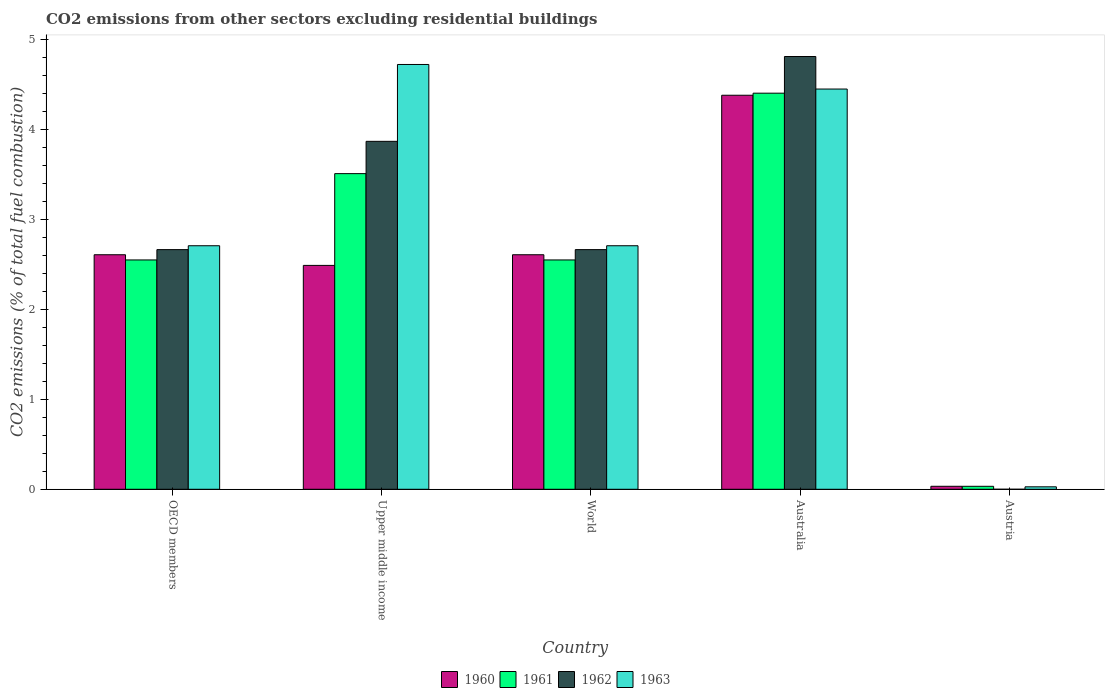How many groups of bars are there?
Give a very brief answer. 5. Are the number of bars per tick equal to the number of legend labels?
Your answer should be compact. No. How many bars are there on the 5th tick from the right?
Make the answer very short. 4. What is the label of the 4th group of bars from the left?
Your answer should be very brief. Australia. In how many cases, is the number of bars for a given country not equal to the number of legend labels?
Provide a succinct answer. 1. What is the total CO2 emitted in 1962 in Australia?
Provide a short and direct response. 4.82. Across all countries, what is the maximum total CO2 emitted in 1963?
Make the answer very short. 4.73. Across all countries, what is the minimum total CO2 emitted in 1962?
Your answer should be very brief. 0. In which country was the total CO2 emitted in 1963 maximum?
Ensure brevity in your answer.  Upper middle income. What is the total total CO2 emitted in 1960 in the graph?
Make the answer very short. 12.13. What is the difference between the total CO2 emitted in 1963 in Australia and that in Upper middle income?
Ensure brevity in your answer.  -0.27. What is the difference between the total CO2 emitted in 1961 in Upper middle income and the total CO2 emitted in 1962 in World?
Give a very brief answer. 0.85. What is the average total CO2 emitted in 1960 per country?
Provide a succinct answer. 2.43. What is the difference between the total CO2 emitted of/in 1963 and total CO2 emitted of/in 1962 in OECD members?
Offer a very short reply. 0.04. What is the ratio of the total CO2 emitted in 1960 in Australia to that in Austria?
Give a very brief answer. 131.83. Is the total CO2 emitted in 1963 in Austria less than that in Upper middle income?
Give a very brief answer. Yes. What is the difference between the highest and the second highest total CO2 emitted in 1960?
Offer a terse response. -1.77. What is the difference between the highest and the lowest total CO2 emitted in 1962?
Offer a very short reply. 4.82. In how many countries, is the total CO2 emitted in 1963 greater than the average total CO2 emitted in 1963 taken over all countries?
Give a very brief answer. 2. Is it the case that in every country, the sum of the total CO2 emitted in 1961 and total CO2 emitted in 1963 is greater than the total CO2 emitted in 1960?
Your response must be concise. Yes. How many bars are there?
Provide a short and direct response. 19. Are all the bars in the graph horizontal?
Ensure brevity in your answer.  No. Does the graph contain any zero values?
Keep it short and to the point. Yes. Where does the legend appear in the graph?
Make the answer very short. Bottom center. How many legend labels are there?
Keep it short and to the point. 4. How are the legend labels stacked?
Ensure brevity in your answer.  Horizontal. What is the title of the graph?
Offer a very short reply. CO2 emissions from other sectors excluding residential buildings. Does "1961" appear as one of the legend labels in the graph?
Give a very brief answer. Yes. What is the label or title of the X-axis?
Keep it short and to the point. Country. What is the label or title of the Y-axis?
Your response must be concise. CO2 emissions (% of total fuel combustion). What is the CO2 emissions (% of total fuel combustion) of 1960 in OECD members?
Offer a terse response. 2.61. What is the CO2 emissions (% of total fuel combustion) of 1961 in OECD members?
Your answer should be compact. 2.55. What is the CO2 emissions (% of total fuel combustion) in 1962 in OECD members?
Offer a very short reply. 2.67. What is the CO2 emissions (% of total fuel combustion) in 1963 in OECD members?
Keep it short and to the point. 2.71. What is the CO2 emissions (% of total fuel combustion) of 1960 in Upper middle income?
Give a very brief answer. 2.49. What is the CO2 emissions (% of total fuel combustion) of 1961 in Upper middle income?
Your response must be concise. 3.51. What is the CO2 emissions (% of total fuel combustion) in 1962 in Upper middle income?
Ensure brevity in your answer.  3.87. What is the CO2 emissions (% of total fuel combustion) in 1963 in Upper middle income?
Provide a short and direct response. 4.73. What is the CO2 emissions (% of total fuel combustion) of 1960 in World?
Ensure brevity in your answer.  2.61. What is the CO2 emissions (% of total fuel combustion) of 1961 in World?
Offer a very short reply. 2.55. What is the CO2 emissions (% of total fuel combustion) of 1962 in World?
Your answer should be very brief. 2.67. What is the CO2 emissions (% of total fuel combustion) in 1963 in World?
Your answer should be compact. 2.71. What is the CO2 emissions (% of total fuel combustion) in 1960 in Australia?
Offer a very short reply. 4.38. What is the CO2 emissions (% of total fuel combustion) of 1961 in Australia?
Offer a terse response. 4.41. What is the CO2 emissions (% of total fuel combustion) of 1962 in Australia?
Your answer should be very brief. 4.82. What is the CO2 emissions (% of total fuel combustion) in 1963 in Australia?
Provide a succinct answer. 4.45. What is the CO2 emissions (% of total fuel combustion) in 1960 in Austria?
Offer a very short reply. 0.03. What is the CO2 emissions (% of total fuel combustion) of 1961 in Austria?
Provide a succinct answer. 0.03. What is the CO2 emissions (% of total fuel combustion) in 1962 in Austria?
Provide a succinct answer. 0. What is the CO2 emissions (% of total fuel combustion) of 1963 in Austria?
Give a very brief answer. 0.03. Across all countries, what is the maximum CO2 emissions (% of total fuel combustion) of 1960?
Your answer should be compact. 4.38. Across all countries, what is the maximum CO2 emissions (% of total fuel combustion) of 1961?
Your response must be concise. 4.41. Across all countries, what is the maximum CO2 emissions (% of total fuel combustion) in 1962?
Provide a succinct answer. 4.82. Across all countries, what is the maximum CO2 emissions (% of total fuel combustion) of 1963?
Keep it short and to the point. 4.73. Across all countries, what is the minimum CO2 emissions (% of total fuel combustion) of 1960?
Provide a succinct answer. 0.03. Across all countries, what is the minimum CO2 emissions (% of total fuel combustion) of 1961?
Give a very brief answer. 0.03. Across all countries, what is the minimum CO2 emissions (% of total fuel combustion) of 1962?
Provide a succinct answer. 0. Across all countries, what is the minimum CO2 emissions (% of total fuel combustion) of 1963?
Give a very brief answer. 0.03. What is the total CO2 emissions (% of total fuel combustion) in 1960 in the graph?
Provide a succinct answer. 12.13. What is the total CO2 emissions (% of total fuel combustion) in 1961 in the graph?
Provide a short and direct response. 13.06. What is the total CO2 emissions (% of total fuel combustion) of 1962 in the graph?
Offer a very short reply. 14.02. What is the total CO2 emissions (% of total fuel combustion) in 1963 in the graph?
Give a very brief answer. 14.63. What is the difference between the CO2 emissions (% of total fuel combustion) of 1960 in OECD members and that in Upper middle income?
Provide a succinct answer. 0.12. What is the difference between the CO2 emissions (% of total fuel combustion) in 1961 in OECD members and that in Upper middle income?
Provide a short and direct response. -0.96. What is the difference between the CO2 emissions (% of total fuel combustion) of 1962 in OECD members and that in Upper middle income?
Offer a very short reply. -1.2. What is the difference between the CO2 emissions (% of total fuel combustion) in 1963 in OECD members and that in Upper middle income?
Your answer should be compact. -2.02. What is the difference between the CO2 emissions (% of total fuel combustion) of 1960 in OECD members and that in Australia?
Provide a succinct answer. -1.77. What is the difference between the CO2 emissions (% of total fuel combustion) in 1961 in OECD members and that in Australia?
Provide a succinct answer. -1.86. What is the difference between the CO2 emissions (% of total fuel combustion) in 1962 in OECD members and that in Australia?
Your answer should be very brief. -2.15. What is the difference between the CO2 emissions (% of total fuel combustion) in 1963 in OECD members and that in Australia?
Give a very brief answer. -1.74. What is the difference between the CO2 emissions (% of total fuel combustion) of 1960 in OECD members and that in Austria?
Ensure brevity in your answer.  2.58. What is the difference between the CO2 emissions (% of total fuel combustion) in 1961 in OECD members and that in Austria?
Your answer should be very brief. 2.52. What is the difference between the CO2 emissions (% of total fuel combustion) of 1963 in OECD members and that in Austria?
Your response must be concise. 2.68. What is the difference between the CO2 emissions (% of total fuel combustion) in 1960 in Upper middle income and that in World?
Your response must be concise. -0.12. What is the difference between the CO2 emissions (% of total fuel combustion) in 1961 in Upper middle income and that in World?
Ensure brevity in your answer.  0.96. What is the difference between the CO2 emissions (% of total fuel combustion) of 1962 in Upper middle income and that in World?
Give a very brief answer. 1.2. What is the difference between the CO2 emissions (% of total fuel combustion) of 1963 in Upper middle income and that in World?
Your answer should be very brief. 2.02. What is the difference between the CO2 emissions (% of total fuel combustion) in 1960 in Upper middle income and that in Australia?
Your answer should be compact. -1.89. What is the difference between the CO2 emissions (% of total fuel combustion) of 1961 in Upper middle income and that in Australia?
Offer a terse response. -0.9. What is the difference between the CO2 emissions (% of total fuel combustion) of 1962 in Upper middle income and that in Australia?
Offer a very short reply. -0.94. What is the difference between the CO2 emissions (% of total fuel combustion) in 1963 in Upper middle income and that in Australia?
Offer a very short reply. 0.27. What is the difference between the CO2 emissions (% of total fuel combustion) of 1960 in Upper middle income and that in Austria?
Ensure brevity in your answer.  2.46. What is the difference between the CO2 emissions (% of total fuel combustion) in 1961 in Upper middle income and that in Austria?
Offer a terse response. 3.48. What is the difference between the CO2 emissions (% of total fuel combustion) in 1963 in Upper middle income and that in Austria?
Your response must be concise. 4.7. What is the difference between the CO2 emissions (% of total fuel combustion) of 1960 in World and that in Australia?
Make the answer very short. -1.77. What is the difference between the CO2 emissions (% of total fuel combustion) of 1961 in World and that in Australia?
Give a very brief answer. -1.86. What is the difference between the CO2 emissions (% of total fuel combustion) of 1962 in World and that in Australia?
Make the answer very short. -2.15. What is the difference between the CO2 emissions (% of total fuel combustion) of 1963 in World and that in Australia?
Give a very brief answer. -1.74. What is the difference between the CO2 emissions (% of total fuel combustion) of 1960 in World and that in Austria?
Ensure brevity in your answer.  2.58. What is the difference between the CO2 emissions (% of total fuel combustion) of 1961 in World and that in Austria?
Your response must be concise. 2.52. What is the difference between the CO2 emissions (% of total fuel combustion) in 1963 in World and that in Austria?
Keep it short and to the point. 2.68. What is the difference between the CO2 emissions (% of total fuel combustion) of 1960 in Australia and that in Austria?
Offer a terse response. 4.35. What is the difference between the CO2 emissions (% of total fuel combustion) of 1961 in Australia and that in Austria?
Provide a succinct answer. 4.37. What is the difference between the CO2 emissions (% of total fuel combustion) of 1963 in Australia and that in Austria?
Your answer should be compact. 4.43. What is the difference between the CO2 emissions (% of total fuel combustion) of 1960 in OECD members and the CO2 emissions (% of total fuel combustion) of 1961 in Upper middle income?
Your answer should be compact. -0.9. What is the difference between the CO2 emissions (% of total fuel combustion) of 1960 in OECD members and the CO2 emissions (% of total fuel combustion) of 1962 in Upper middle income?
Offer a terse response. -1.26. What is the difference between the CO2 emissions (% of total fuel combustion) in 1960 in OECD members and the CO2 emissions (% of total fuel combustion) in 1963 in Upper middle income?
Your response must be concise. -2.12. What is the difference between the CO2 emissions (% of total fuel combustion) in 1961 in OECD members and the CO2 emissions (% of total fuel combustion) in 1962 in Upper middle income?
Provide a short and direct response. -1.32. What is the difference between the CO2 emissions (% of total fuel combustion) in 1961 in OECD members and the CO2 emissions (% of total fuel combustion) in 1963 in Upper middle income?
Provide a succinct answer. -2.17. What is the difference between the CO2 emissions (% of total fuel combustion) of 1962 in OECD members and the CO2 emissions (% of total fuel combustion) of 1963 in Upper middle income?
Offer a terse response. -2.06. What is the difference between the CO2 emissions (% of total fuel combustion) of 1960 in OECD members and the CO2 emissions (% of total fuel combustion) of 1961 in World?
Provide a short and direct response. 0.06. What is the difference between the CO2 emissions (% of total fuel combustion) of 1960 in OECD members and the CO2 emissions (% of total fuel combustion) of 1962 in World?
Make the answer very short. -0.06. What is the difference between the CO2 emissions (% of total fuel combustion) of 1960 in OECD members and the CO2 emissions (% of total fuel combustion) of 1963 in World?
Provide a short and direct response. -0.1. What is the difference between the CO2 emissions (% of total fuel combustion) in 1961 in OECD members and the CO2 emissions (% of total fuel combustion) in 1962 in World?
Your answer should be very brief. -0.12. What is the difference between the CO2 emissions (% of total fuel combustion) of 1961 in OECD members and the CO2 emissions (% of total fuel combustion) of 1963 in World?
Provide a succinct answer. -0.16. What is the difference between the CO2 emissions (% of total fuel combustion) of 1962 in OECD members and the CO2 emissions (% of total fuel combustion) of 1963 in World?
Provide a succinct answer. -0.04. What is the difference between the CO2 emissions (% of total fuel combustion) in 1960 in OECD members and the CO2 emissions (% of total fuel combustion) in 1961 in Australia?
Keep it short and to the point. -1.8. What is the difference between the CO2 emissions (% of total fuel combustion) in 1960 in OECD members and the CO2 emissions (% of total fuel combustion) in 1962 in Australia?
Offer a very short reply. -2.21. What is the difference between the CO2 emissions (% of total fuel combustion) of 1960 in OECD members and the CO2 emissions (% of total fuel combustion) of 1963 in Australia?
Offer a very short reply. -1.84. What is the difference between the CO2 emissions (% of total fuel combustion) of 1961 in OECD members and the CO2 emissions (% of total fuel combustion) of 1962 in Australia?
Keep it short and to the point. -2.26. What is the difference between the CO2 emissions (% of total fuel combustion) in 1961 in OECD members and the CO2 emissions (% of total fuel combustion) in 1963 in Australia?
Your answer should be very brief. -1.9. What is the difference between the CO2 emissions (% of total fuel combustion) of 1962 in OECD members and the CO2 emissions (% of total fuel combustion) of 1963 in Australia?
Offer a very short reply. -1.79. What is the difference between the CO2 emissions (% of total fuel combustion) in 1960 in OECD members and the CO2 emissions (% of total fuel combustion) in 1961 in Austria?
Give a very brief answer. 2.58. What is the difference between the CO2 emissions (% of total fuel combustion) of 1960 in OECD members and the CO2 emissions (% of total fuel combustion) of 1963 in Austria?
Your answer should be compact. 2.58. What is the difference between the CO2 emissions (% of total fuel combustion) in 1961 in OECD members and the CO2 emissions (% of total fuel combustion) in 1963 in Austria?
Your response must be concise. 2.52. What is the difference between the CO2 emissions (% of total fuel combustion) of 1962 in OECD members and the CO2 emissions (% of total fuel combustion) of 1963 in Austria?
Offer a terse response. 2.64. What is the difference between the CO2 emissions (% of total fuel combustion) of 1960 in Upper middle income and the CO2 emissions (% of total fuel combustion) of 1961 in World?
Offer a very short reply. -0.06. What is the difference between the CO2 emissions (% of total fuel combustion) in 1960 in Upper middle income and the CO2 emissions (% of total fuel combustion) in 1962 in World?
Make the answer very short. -0.18. What is the difference between the CO2 emissions (% of total fuel combustion) of 1960 in Upper middle income and the CO2 emissions (% of total fuel combustion) of 1963 in World?
Offer a very short reply. -0.22. What is the difference between the CO2 emissions (% of total fuel combustion) of 1961 in Upper middle income and the CO2 emissions (% of total fuel combustion) of 1962 in World?
Give a very brief answer. 0.85. What is the difference between the CO2 emissions (% of total fuel combustion) of 1961 in Upper middle income and the CO2 emissions (% of total fuel combustion) of 1963 in World?
Ensure brevity in your answer.  0.8. What is the difference between the CO2 emissions (% of total fuel combustion) of 1962 in Upper middle income and the CO2 emissions (% of total fuel combustion) of 1963 in World?
Give a very brief answer. 1.16. What is the difference between the CO2 emissions (% of total fuel combustion) of 1960 in Upper middle income and the CO2 emissions (% of total fuel combustion) of 1961 in Australia?
Your answer should be compact. -1.92. What is the difference between the CO2 emissions (% of total fuel combustion) in 1960 in Upper middle income and the CO2 emissions (% of total fuel combustion) in 1962 in Australia?
Give a very brief answer. -2.32. What is the difference between the CO2 emissions (% of total fuel combustion) in 1960 in Upper middle income and the CO2 emissions (% of total fuel combustion) in 1963 in Australia?
Keep it short and to the point. -1.96. What is the difference between the CO2 emissions (% of total fuel combustion) of 1961 in Upper middle income and the CO2 emissions (% of total fuel combustion) of 1962 in Australia?
Give a very brief answer. -1.3. What is the difference between the CO2 emissions (% of total fuel combustion) of 1961 in Upper middle income and the CO2 emissions (% of total fuel combustion) of 1963 in Australia?
Give a very brief answer. -0.94. What is the difference between the CO2 emissions (% of total fuel combustion) in 1962 in Upper middle income and the CO2 emissions (% of total fuel combustion) in 1963 in Australia?
Give a very brief answer. -0.58. What is the difference between the CO2 emissions (% of total fuel combustion) in 1960 in Upper middle income and the CO2 emissions (% of total fuel combustion) in 1961 in Austria?
Ensure brevity in your answer.  2.46. What is the difference between the CO2 emissions (% of total fuel combustion) in 1960 in Upper middle income and the CO2 emissions (% of total fuel combustion) in 1963 in Austria?
Give a very brief answer. 2.46. What is the difference between the CO2 emissions (% of total fuel combustion) in 1961 in Upper middle income and the CO2 emissions (% of total fuel combustion) in 1963 in Austria?
Make the answer very short. 3.48. What is the difference between the CO2 emissions (% of total fuel combustion) of 1962 in Upper middle income and the CO2 emissions (% of total fuel combustion) of 1963 in Austria?
Make the answer very short. 3.84. What is the difference between the CO2 emissions (% of total fuel combustion) of 1960 in World and the CO2 emissions (% of total fuel combustion) of 1961 in Australia?
Your answer should be compact. -1.8. What is the difference between the CO2 emissions (% of total fuel combustion) of 1960 in World and the CO2 emissions (% of total fuel combustion) of 1962 in Australia?
Offer a very short reply. -2.21. What is the difference between the CO2 emissions (% of total fuel combustion) in 1960 in World and the CO2 emissions (% of total fuel combustion) in 1963 in Australia?
Provide a short and direct response. -1.84. What is the difference between the CO2 emissions (% of total fuel combustion) in 1961 in World and the CO2 emissions (% of total fuel combustion) in 1962 in Australia?
Offer a very short reply. -2.26. What is the difference between the CO2 emissions (% of total fuel combustion) of 1961 in World and the CO2 emissions (% of total fuel combustion) of 1963 in Australia?
Your answer should be very brief. -1.9. What is the difference between the CO2 emissions (% of total fuel combustion) of 1962 in World and the CO2 emissions (% of total fuel combustion) of 1963 in Australia?
Make the answer very short. -1.79. What is the difference between the CO2 emissions (% of total fuel combustion) of 1960 in World and the CO2 emissions (% of total fuel combustion) of 1961 in Austria?
Provide a short and direct response. 2.58. What is the difference between the CO2 emissions (% of total fuel combustion) in 1960 in World and the CO2 emissions (% of total fuel combustion) in 1963 in Austria?
Your response must be concise. 2.58. What is the difference between the CO2 emissions (% of total fuel combustion) in 1961 in World and the CO2 emissions (% of total fuel combustion) in 1963 in Austria?
Your answer should be very brief. 2.52. What is the difference between the CO2 emissions (% of total fuel combustion) in 1962 in World and the CO2 emissions (% of total fuel combustion) in 1963 in Austria?
Make the answer very short. 2.64. What is the difference between the CO2 emissions (% of total fuel combustion) of 1960 in Australia and the CO2 emissions (% of total fuel combustion) of 1961 in Austria?
Offer a terse response. 4.35. What is the difference between the CO2 emissions (% of total fuel combustion) of 1960 in Australia and the CO2 emissions (% of total fuel combustion) of 1963 in Austria?
Ensure brevity in your answer.  4.36. What is the difference between the CO2 emissions (% of total fuel combustion) of 1961 in Australia and the CO2 emissions (% of total fuel combustion) of 1963 in Austria?
Provide a succinct answer. 4.38. What is the difference between the CO2 emissions (% of total fuel combustion) of 1962 in Australia and the CO2 emissions (% of total fuel combustion) of 1963 in Austria?
Make the answer very short. 4.79. What is the average CO2 emissions (% of total fuel combustion) in 1960 per country?
Provide a succinct answer. 2.43. What is the average CO2 emissions (% of total fuel combustion) of 1961 per country?
Make the answer very short. 2.61. What is the average CO2 emissions (% of total fuel combustion) in 1962 per country?
Your answer should be very brief. 2.8. What is the average CO2 emissions (% of total fuel combustion) in 1963 per country?
Give a very brief answer. 2.93. What is the difference between the CO2 emissions (% of total fuel combustion) in 1960 and CO2 emissions (% of total fuel combustion) in 1961 in OECD members?
Provide a succinct answer. 0.06. What is the difference between the CO2 emissions (% of total fuel combustion) of 1960 and CO2 emissions (% of total fuel combustion) of 1962 in OECD members?
Your answer should be compact. -0.06. What is the difference between the CO2 emissions (% of total fuel combustion) of 1960 and CO2 emissions (% of total fuel combustion) of 1963 in OECD members?
Your answer should be compact. -0.1. What is the difference between the CO2 emissions (% of total fuel combustion) of 1961 and CO2 emissions (% of total fuel combustion) of 1962 in OECD members?
Keep it short and to the point. -0.12. What is the difference between the CO2 emissions (% of total fuel combustion) of 1961 and CO2 emissions (% of total fuel combustion) of 1963 in OECD members?
Give a very brief answer. -0.16. What is the difference between the CO2 emissions (% of total fuel combustion) of 1962 and CO2 emissions (% of total fuel combustion) of 1963 in OECD members?
Provide a short and direct response. -0.04. What is the difference between the CO2 emissions (% of total fuel combustion) of 1960 and CO2 emissions (% of total fuel combustion) of 1961 in Upper middle income?
Ensure brevity in your answer.  -1.02. What is the difference between the CO2 emissions (% of total fuel combustion) of 1960 and CO2 emissions (% of total fuel combustion) of 1962 in Upper middle income?
Your answer should be very brief. -1.38. What is the difference between the CO2 emissions (% of total fuel combustion) in 1960 and CO2 emissions (% of total fuel combustion) in 1963 in Upper middle income?
Your answer should be compact. -2.24. What is the difference between the CO2 emissions (% of total fuel combustion) of 1961 and CO2 emissions (% of total fuel combustion) of 1962 in Upper middle income?
Give a very brief answer. -0.36. What is the difference between the CO2 emissions (% of total fuel combustion) of 1961 and CO2 emissions (% of total fuel combustion) of 1963 in Upper middle income?
Provide a short and direct response. -1.21. What is the difference between the CO2 emissions (% of total fuel combustion) in 1962 and CO2 emissions (% of total fuel combustion) in 1963 in Upper middle income?
Your response must be concise. -0.85. What is the difference between the CO2 emissions (% of total fuel combustion) of 1960 and CO2 emissions (% of total fuel combustion) of 1961 in World?
Provide a short and direct response. 0.06. What is the difference between the CO2 emissions (% of total fuel combustion) in 1960 and CO2 emissions (% of total fuel combustion) in 1962 in World?
Your response must be concise. -0.06. What is the difference between the CO2 emissions (% of total fuel combustion) in 1960 and CO2 emissions (% of total fuel combustion) in 1963 in World?
Ensure brevity in your answer.  -0.1. What is the difference between the CO2 emissions (% of total fuel combustion) of 1961 and CO2 emissions (% of total fuel combustion) of 1962 in World?
Your response must be concise. -0.12. What is the difference between the CO2 emissions (% of total fuel combustion) of 1961 and CO2 emissions (% of total fuel combustion) of 1963 in World?
Give a very brief answer. -0.16. What is the difference between the CO2 emissions (% of total fuel combustion) in 1962 and CO2 emissions (% of total fuel combustion) in 1963 in World?
Make the answer very short. -0.04. What is the difference between the CO2 emissions (% of total fuel combustion) in 1960 and CO2 emissions (% of total fuel combustion) in 1961 in Australia?
Offer a very short reply. -0.02. What is the difference between the CO2 emissions (% of total fuel combustion) in 1960 and CO2 emissions (% of total fuel combustion) in 1962 in Australia?
Your answer should be compact. -0.43. What is the difference between the CO2 emissions (% of total fuel combustion) in 1960 and CO2 emissions (% of total fuel combustion) in 1963 in Australia?
Provide a succinct answer. -0.07. What is the difference between the CO2 emissions (% of total fuel combustion) of 1961 and CO2 emissions (% of total fuel combustion) of 1962 in Australia?
Your response must be concise. -0.41. What is the difference between the CO2 emissions (% of total fuel combustion) in 1961 and CO2 emissions (% of total fuel combustion) in 1963 in Australia?
Offer a very short reply. -0.05. What is the difference between the CO2 emissions (% of total fuel combustion) of 1962 and CO2 emissions (% of total fuel combustion) of 1963 in Australia?
Keep it short and to the point. 0.36. What is the difference between the CO2 emissions (% of total fuel combustion) in 1960 and CO2 emissions (% of total fuel combustion) in 1961 in Austria?
Your answer should be very brief. 0. What is the difference between the CO2 emissions (% of total fuel combustion) of 1960 and CO2 emissions (% of total fuel combustion) of 1963 in Austria?
Ensure brevity in your answer.  0.01. What is the difference between the CO2 emissions (% of total fuel combustion) in 1961 and CO2 emissions (% of total fuel combustion) in 1963 in Austria?
Your answer should be very brief. 0.01. What is the ratio of the CO2 emissions (% of total fuel combustion) in 1960 in OECD members to that in Upper middle income?
Your response must be concise. 1.05. What is the ratio of the CO2 emissions (% of total fuel combustion) of 1961 in OECD members to that in Upper middle income?
Ensure brevity in your answer.  0.73. What is the ratio of the CO2 emissions (% of total fuel combustion) of 1962 in OECD members to that in Upper middle income?
Your answer should be compact. 0.69. What is the ratio of the CO2 emissions (% of total fuel combustion) of 1963 in OECD members to that in Upper middle income?
Your answer should be compact. 0.57. What is the ratio of the CO2 emissions (% of total fuel combustion) of 1960 in OECD members to that in World?
Your answer should be compact. 1. What is the ratio of the CO2 emissions (% of total fuel combustion) of 1962 in OECD members to that in World?
Provide a succinct answer. 1. What is the ratio of the CO2 emissions (% of total fuel combustion) in 1960 in OECD members to that in Australia?
Provide a short and direct response. 0.6. What is the ratio of the CO2 emissions (% of total fuel combustion) of 1961 in OECD members to that in Australia?
Your answer should be compact. 0.58. What is the ratio of the CO2 emissions (% of total fuel combustion) of 1962 in OECD members to that in Australia?
Offer a very short reply. 0.55. What is the ratio of the CO2 emissions (% of total fuel combustion) in 1963 in OECD members to that in Australia?
Offer a very short reply. 0.61. What is the ratio of the CO2 emissions (% of total fuel combustion) in 1960 in OECD members to that in Austria?
Provide a short and direct response. 78.47. What is the ratio of the CO2 emissions (% of total fuel combustion) of 1961 in OECD members to that in Austria?
Ensure brevity in your answer.  77.37. What is the ratio of the CO2 emissions (% of total fuel combustion) in 1963 in OECD members to that in Austria?
Offer a very short reply. 99.22. What is the ratio of the CO2 emissions (% of total fuel combustion) of 1960 in Upper middle income to that in World?
Keep it short and to the point. 0.95. What is the ratio of the CO2 emissions (% of total fuel combustion) of 1961 in Upper middle income to that in World?
Offer a very short reply. 1.38. What is the ratio of the CO2 emissions (% of total fuel combustion) of 1962 in Upper middle income to that in World?
Offer a terse response. 1.45. What is the ratio of the CO2 emissions (% of total fuel combustion) of 1963 in Upper middle income to that in World?
Provide a short and direct response. 1.74. What is the ratio of the CO2 emissions (% of total fuel combustion) in 1960 in Upper middle income to that in Australia?
Offer a terse response. 0.57. What is the ratio of the CO2 emissions (% of total fuel combustion) in 1961 in Upper middle income to that in Australia?
Ensure brevity in your answer.  0.8. What is the ratio of the CO2 emissions (% of total fuel combustion) in 1962 in Upper middle income to that in Australia?
Keep it short and to the point. 0.8. What is the ratio of the CO2 emissions (% of total fuel combustion) of 1963 in Upper middle income to that in Australia?
Ensure brevity in your answer.  1.06. What is the ratio of the CO2 emissions (% of total fuel combustion) of 1960 in Upper middle income to that in Austria?
Make the answer very short. 74.9. What is the ratio of the CO2 emissions (% of total fuel combustion) in 1961 in Upper middle income to that in Austria?
Ensure brevity in your answer.  106.48. What is the ratio of the CO2 emissions (% of total fuel combustion) in 1963 in Upper middle income to that in Austria?
Your answer should be compact. 173.08. What is the ratio of the CO2 emissions (% of total fuel combustion) in 1960 in World to that in Australia?
Keep it short and to the point. 0.6. What is the ratio of the CO2 emissions (% of total fuel combustion) of 1961 in World to that in Australia?
Offer a very short reply. 0.58. What is the ratio of the CO2 emissions (% of total fuel combustion) of 1962 in World to that in Australia?
Give a very brief answer. 0.55. What is the ratio of the CO2 emissions (% of total fuel combustion) in 1963 in World to that in Australia?
Ensure brevity in your answer.  0.61. What is the ratio of the CO2 emissions (% of total fuel combustion) in 1960 in World to that in Austria?
Keep it short and to the point. 78.47. What is the ratio of the CO2 emissions (% of total fuel combustion) in 1961 in World to that in Austria?
Make the answer very short. 77.37. What is the ratio of the CO2 emissions (% of total fuel combustion) of 1963 in World to that in Austria?
Give a very brief answer. 99.22. What is the ratio of the CO2 emissions (% of total fuel combustion) in 1960 in Australia to that in Austria?
Provide a succinct answer. 131.83. What is the ratio of the CO2 emissions (% of total fuel combustion) of 1961 in Australia to that in Austria?
Give a very brief answer. 133.62. What is the ratio of the CO2 emissions (% of total fuel combustion) in 1963 in Australia to that in Austria?
Ensure brevity in your answer.  163.07. What is the difference between the highest and the second highest CO2 emissions (% of total fuel combustion) in 1960?
Provide a succinct answer. 1.77. What is the difference between the highest and the second highest CO2 emissions (% of total fuel combustion) in 1961?
Ensure brevity in your answer.  0.9. What is the difference between the highest and the second highest CO2 emissions (% of total fuel combustion) in 1962?
Keep it short and to the point. 0.94. What is the difference between the highest and the second highest CO2 emissions (% of total fuel combustion) of 1963?
Offer a very short reply. 0.27. What is the difference between the highest and the lowest CO2 emissions (% of total fuel combustion) in 1960?
Your answer should be very brief. 4.35. What is the difference between the highest and the lowest CO2 emissions (% of total fuel combustion) of 1961?
Ensure brevity in your answer.  4.37. What is the difference between the highest and the lowest CO2 emissions (% of total fuel combustion) of 1962?
Ensure brevity in your answer.  4.82. What is the difference between the highest and the lowest CO2 emissions (% of total fuel combustion) of 1963?
Offer a terse response. 4.7. 